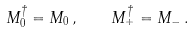Convert formula to latex. <formula><loc_0><loc_0><loc_500><loc_500>M _ { 0 } ^ { \dagger } = M _ { 0 } \, , \quad M _ { + } ^ { \dagger } = M _ { - } \, .</formula> 